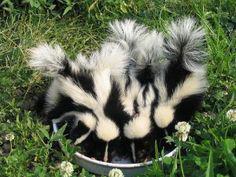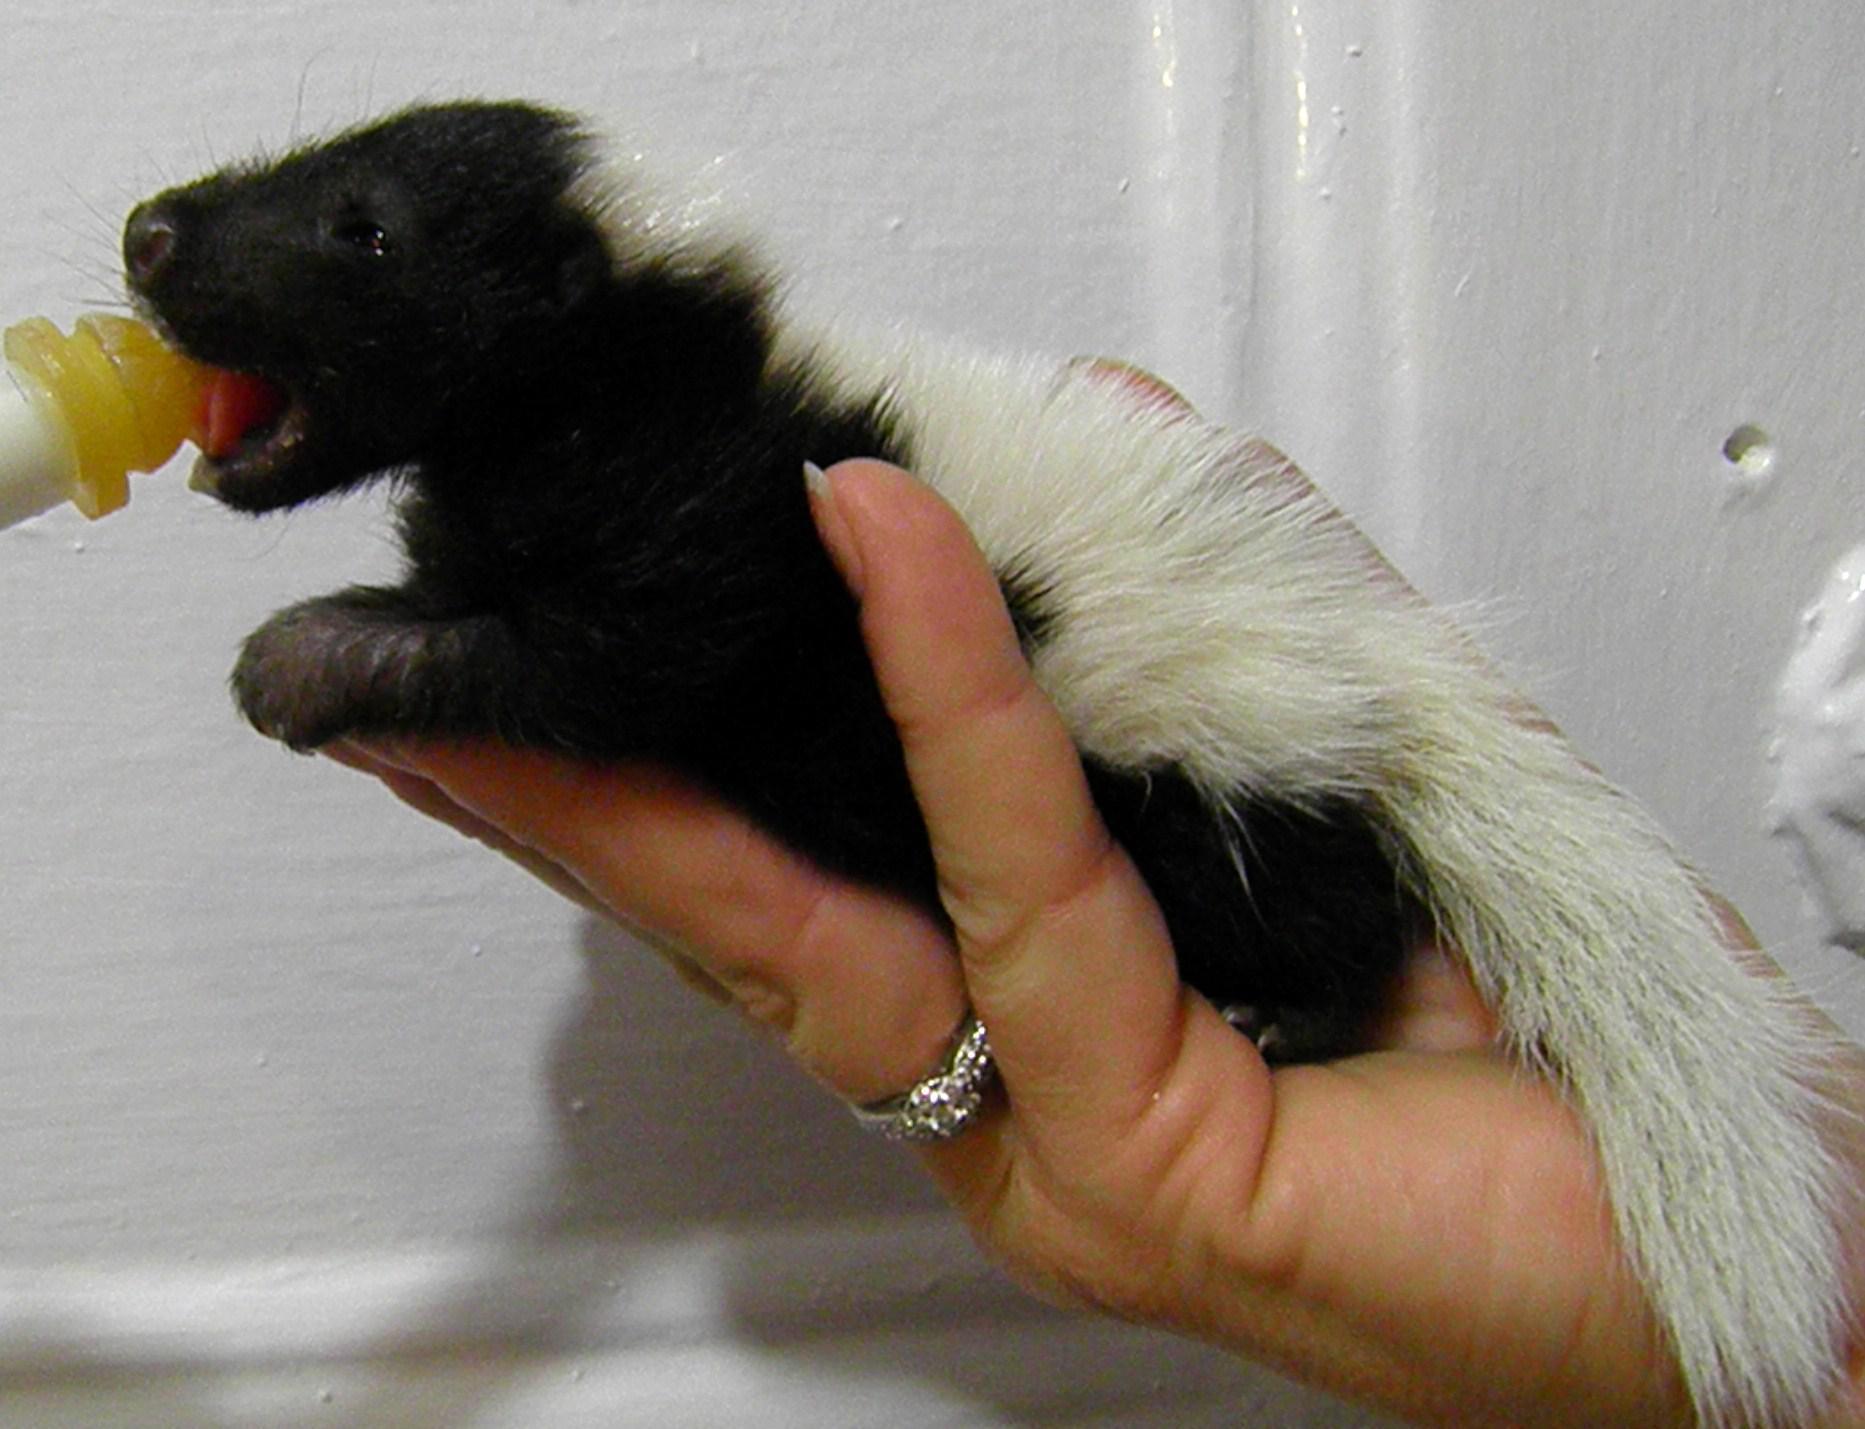The first image is the image on the left, the second image is the image on the right. Examine the images to the left and right. Is the description "The skunk in the right image is being bottle fed." accurate? Answer yes or no. Yes. 